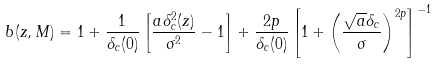<formula> <loc_0><loc_0><loc_500><loc_500>b ( z , M ) = 1 + \frac { 1 } { \delta _ { c } ( 0 ) } \left [ \frac { a \delta ^ { 2 } _ { c } ( z ) } { \sigma ^ { 2 } } - 1 \right ] + \frac { 2 p } { \delta _ { c } ( 0 ) } \left [ 1 + \left ( \frac { \sqrt { a } \delta _ { c } } { \sigma } \right ) ^ { 2 p } \right ] ^ { - 1 }</formula> 